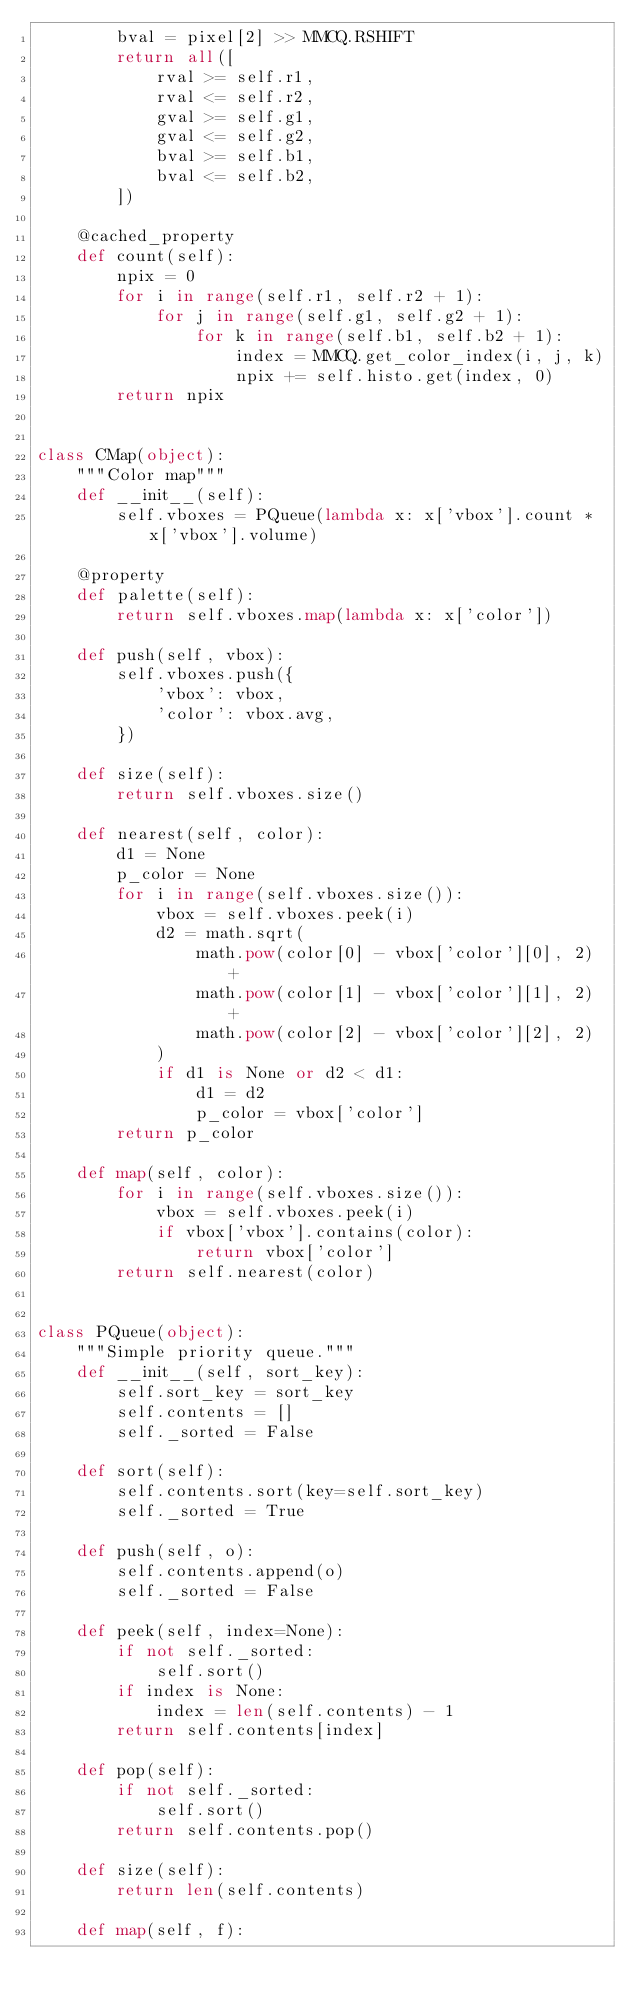<code> <loc_0><loc_0><loc_500><loc_500><_Python_>        bval = pixel[2] >> MMCQ.RSHIFT
        return all([
            rval >= self.r1,
            rval <= self.r2,
            gval >= self.g1,
            gval <= self.g2,
            bval >= self.b1,
            bval <= self.b2,
        ])

    @cached_property
    def count(self):
        npix = 0
        for i in range(self.r1, self.r2 + 1):
            for j in range(self.g1, self.g2 + 1):
                for k in range(self.b1, self.b2 + 1):
                    index = MMCQ.get_color_index(i, j, k)
                    npix += self.histo.get(index, 0)
        return npix


class CMap(object):
    """Color map"""
    def __init__(self):
        self.vboxes = PQueue(lambda x: x['vbox'].count * x['vbox'].volume)

    @property
    def palette(self):
        return self.vboxes.map(lambda x: x['color'])

    def push(self, vbox):
        self.vboxes.push({
            'vbox': vbox,
            'color': vbox.avg,
        })

    def size(self):
        return self.vboxes.size()

    def nearest(self, color):
        d1 = None
        p_color = None
        for i in range(self.vboxes.size()):
            vbox = self.vboxes.peek(i)
            d2 = math.sqrt(
                math.pow(color[0] - vbox['color'][0], 2) +
                math.pow(color[1] - vbox['color'][1], 2) +
                math.pow(color[2] - vbox['color'][2], 2)
            )
            if d1 is None or d2 < d1:
                d1 = d2
                p_color = vbox['color']
        return p_color

    def map(self, color):
        for i in range(self.vboxes.size()):
            vbox = self.vboxes.peek(i)
            if vbox['vbox'].contains(color):
                return vbox['color']
        return self.nearest(color)


class PQueue(object):
    """Simple priority queue."""
    def __init__(self, sort_key):
        self.sort_key = sort_key
        self.contents = []
        self._sorted = False

    def sort(self):
        self.contents.sort(key=self.sort_key)
        self._sorted = True

    def push(self, o):
        self.contents.append(o)
        self._sorted = False

    def peek(self, index=None):
        if not self._sorted:
            self.sort()
        if index is None:
            index = len(self.contents) - 1
        return self.contents[index]

    def pop(self):
        if not self._sorted:
            self.sort()
        return self.contents.pop()

    def size(self):
        return len(self.contents)

    def map(self, f):</code> 